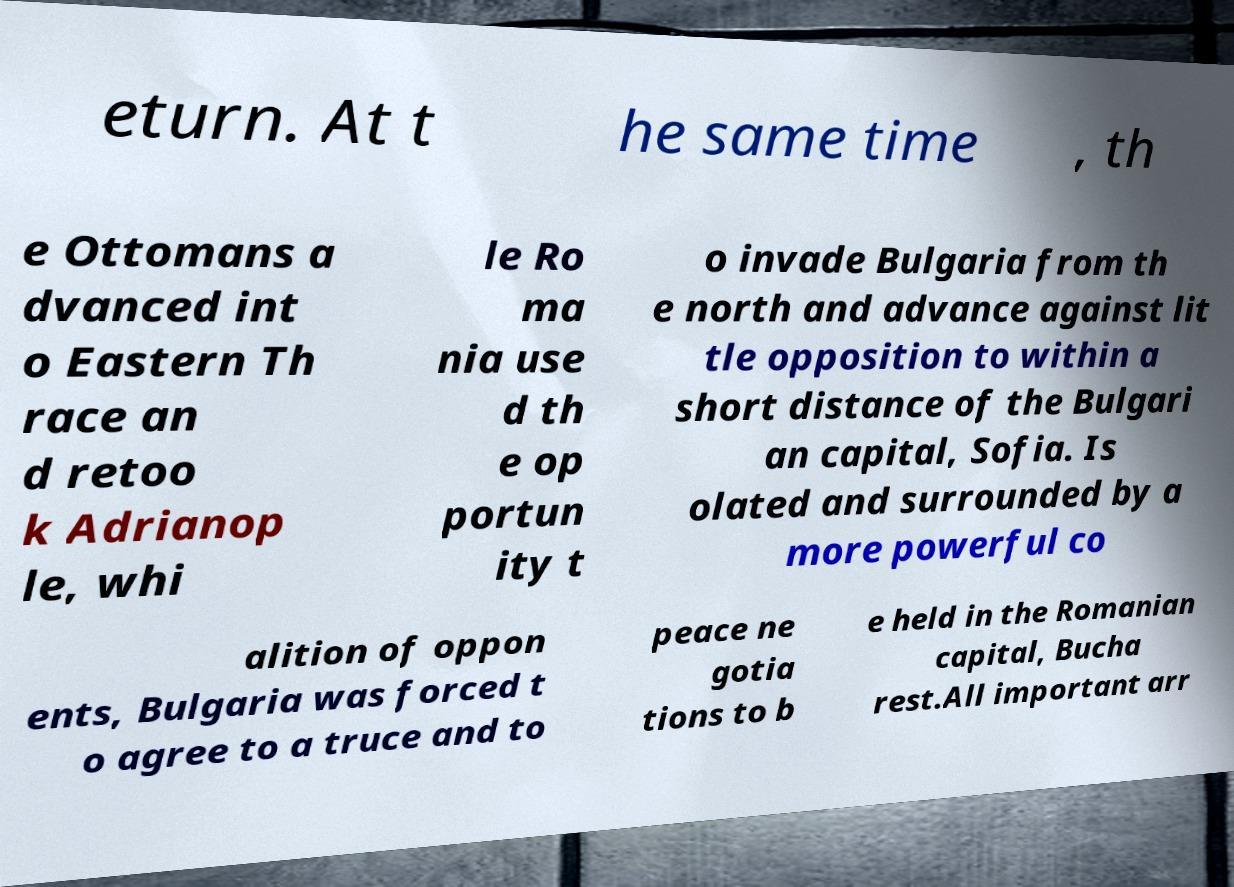Could you extract and type out the text from this image? eturn. At t he same time , th e Ottomans a dvanced int o Eastern Th race an d retoo k Adrianop le, whi le Ro ma nia use d th e op portun ity t o invade Bulgaria from th e north and advance against lit tle opposition to within a short distance of the Bulgari an capital, Sofia. Is olated and surrounded by a more powerful co alition of oppon ents, Bulgaria was forced t o agree to a truce and to peace ne gotia tions to b e held in the Romanian capital, Bucha rest.All important arr 